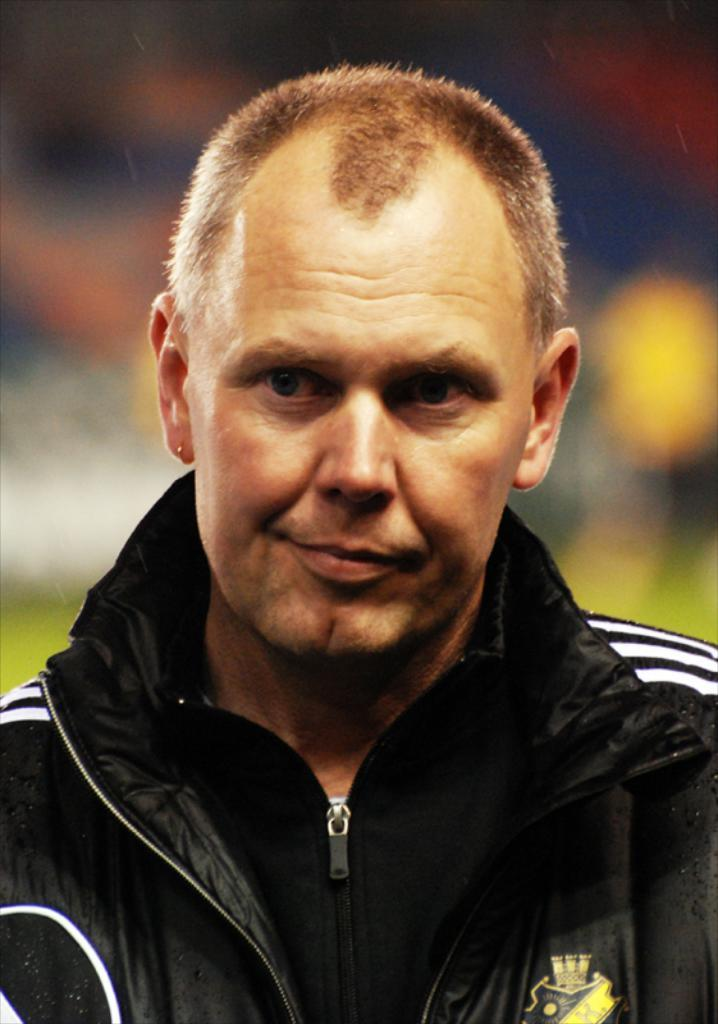What is the main subject of the image? There is a person in the image. What is the person wearing in the image? The person is wearing a black dress. Can you describe the background of the image? The background of the image is blurred. What type of degree does the person in the image hold? There is no information about the person's degree in the image. Can you tell me what type of wilderness is visible in the background of the image? There is no wilderness visible in the image, as the background is blurred. 